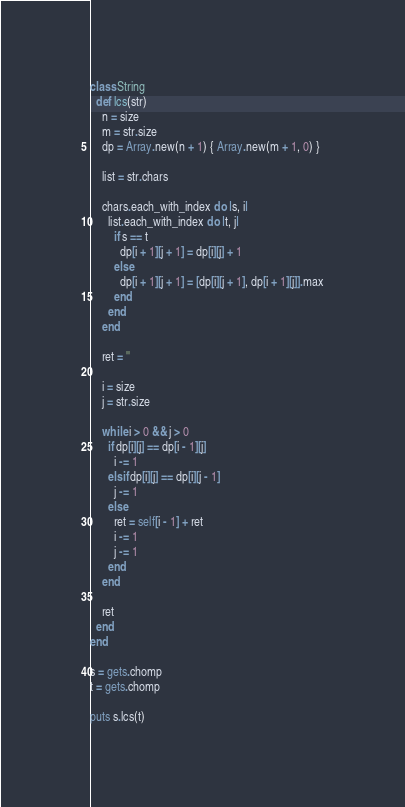<code> <loc_0><loc_0><loc_500><loc_500><_Ruby_>class String
  def lcs(str)
    n = size
    m = str.size
    dp = Array.new(n + 1) { Array.new(m + 1, 0) }

    list = str.chars

    chars.each_with_index do |s, i|
      list.each_with_index do |t, j|
        if s == t
          dp[i + 1][j + 1] = dp[i][j] + 1
        else
          dp[i + 1][j + 1] = [dp[i][j + 1], dp[i + 1][j]].max
        end
      end
    end

    ret = ''

    i = size
    j = str.size

    while i > 0 && j > 0
      if dp[i][j] == dp[i - 1][j]
        i -= 1
      elsif dp[i][j] == dp[i][j - 1]
        j -= 1
      else
        ret = self[i - 1] + ret
        i -= 1
        j -= 1
      end
    end

    ret
  end
end

s = gets.chomp
t = gets.chomp

puts s.lcs(t)
</code> 